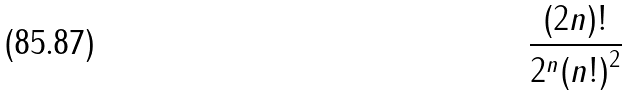Convert formula to latex. <formula><loc_0><loc_0><loc_500><loc_500>\frac { ( 2 n ) ! } { 2 ^ { n } { ( n ! ) } ^ { 2 } }</formula> 